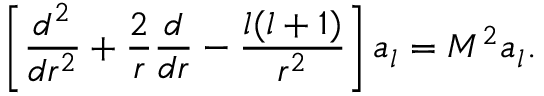<formula> <loc_0><loc_0><loc_500><loc_500>\left [ { \frac { d ^ { 2 } } { d r ^ { 2 } } } + { \frac { 2 } { r } } { \frac { d } { d r } } - { \frac { l ( l + 1 ) } { r ^ { 2 } } } \right ] a _ { l } = M ^ { 2 } a _ { l } .</formula> 